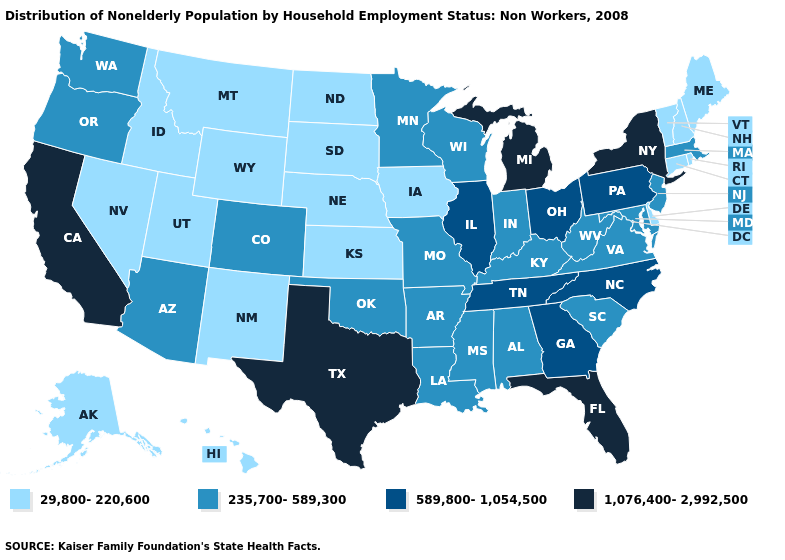What is the value of New Hampshire?
Give a very brief answer. 29,800-220,600. Name the states that have a value in the range 589,800-1,054,500?
Write a very short answer. Georgia, Illinois, North Carolina, Ohio, Pennsylvania, Tennessee. Does the first symbol in the legend represent the smallest category?
Write a very short answer. Yes. Among the states that border Kansas , which have the lowest value?
Short answer required. Nebraska. Which states have the lowest value in the USA?
Be succinct. Alaska, Connecticut, Delaware, Hawaii, Idaho, Iowa, Kansas, Maine, Montana, Nebraska, Nevada, New Hampshire, New Mexico, North Dakota, Rhode Island, South Dakota, Utah, Vermont, Wyoming. What is the value of Nevada?
Give a very brief answer. 29,800-220,600. Among the states that border Maine , which have the highest value?
Give a very brief answer. New Hampshire. Does New York have the highest value in the Northeast?
Quick response, please. Yes. Is the legend a continuous bar?
Short answer required. No. What is the lowest value in states that border Idaho?
Be succinct. 29,800-220,600. What is the value of Alaska?
Be succinct. 29,800-220,600. Which states have the lowest value in the Northeast?
Quick response, please. Connecticut, Maine, New Hampshire, Rhode Island, Vermont. What is the value of Massachusetts?
Give a very brief answer. 235,700-589,300. What is the value of Colorado?
Give a very brief answer. 235,700-589,300. What is the value of Utah?
Be succinct. 29,800-220,600. 